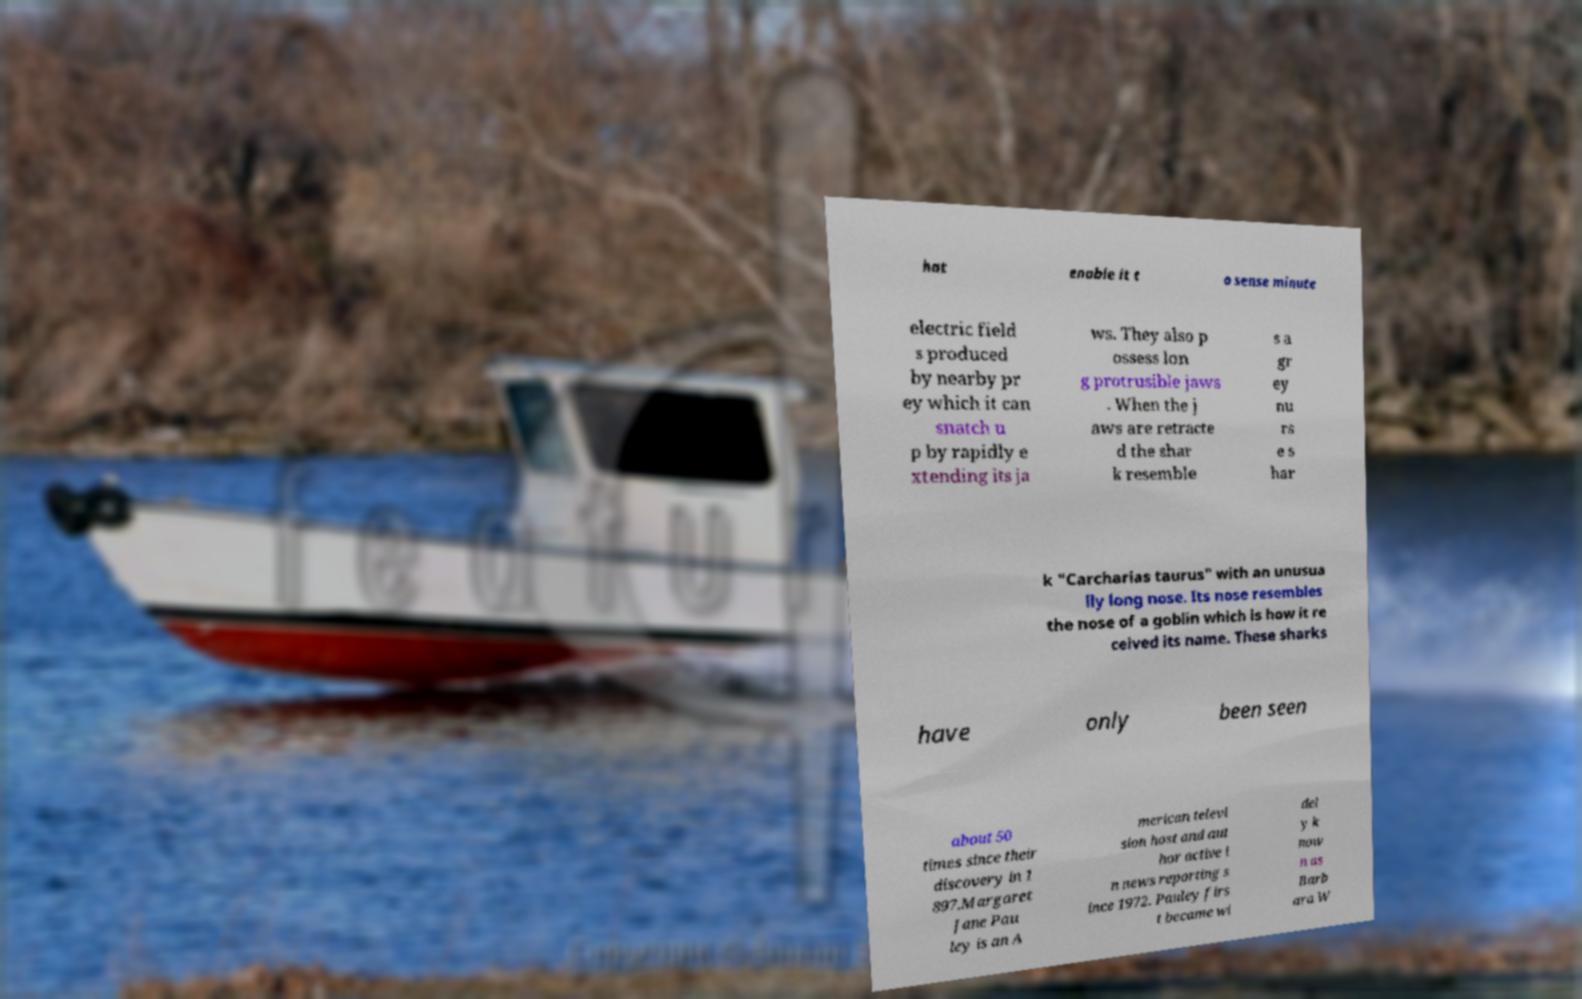Please read and relay the text visible in this image. What does it say? hat enable it t o sense minute electric field s produced by nearby pr ey which it can snatch u p by rapidly e xtending its ja ws. They also p ossess lon g protrusible jaws . When the j aws are retracte d the shar k resemble s a gr ey nu rs e s har k "Carcharias taurus" with an unusua lly long nose. Its nose resembles the nose of a goblin which is how it re ceived its name. These sharks have only been seen about 50 times since their discovery in 1 897.Margaret Jane Pau ley is an A merican televi sion host and aut hor active i n news reporting s ince 1972. Pauley firs t became wi del y k now n as Barb ara W 